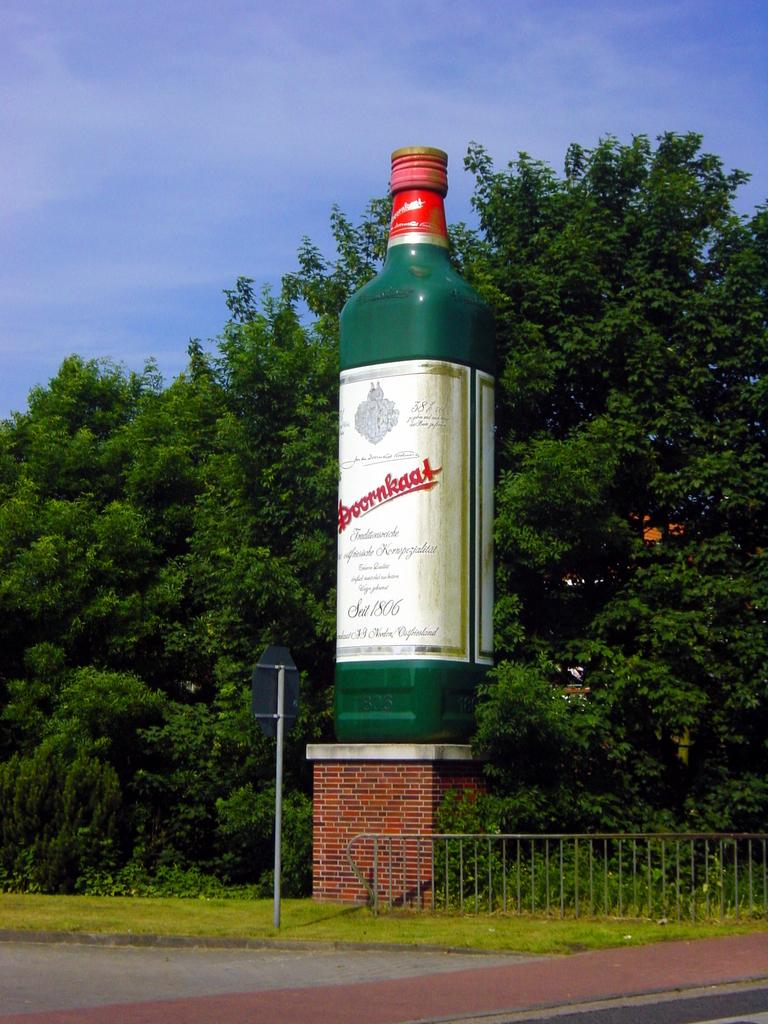<image>
Render a clear and concise summary of the photo. Large green bottle which says "DOORNKAAT" on it next to some trees. 